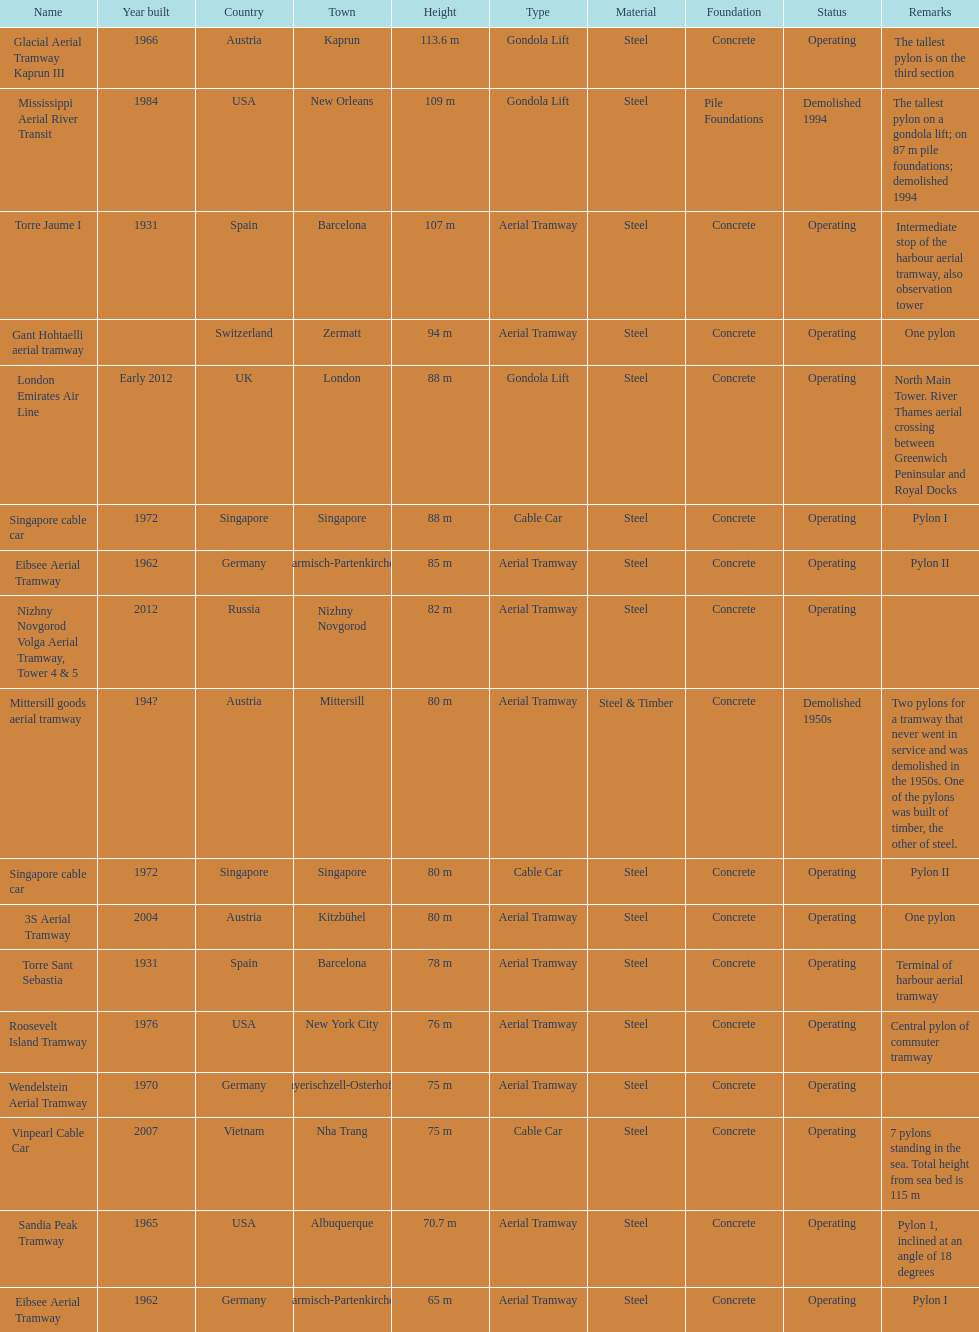Which pylon is the least tall? Eibsee Aerial Tramway. 